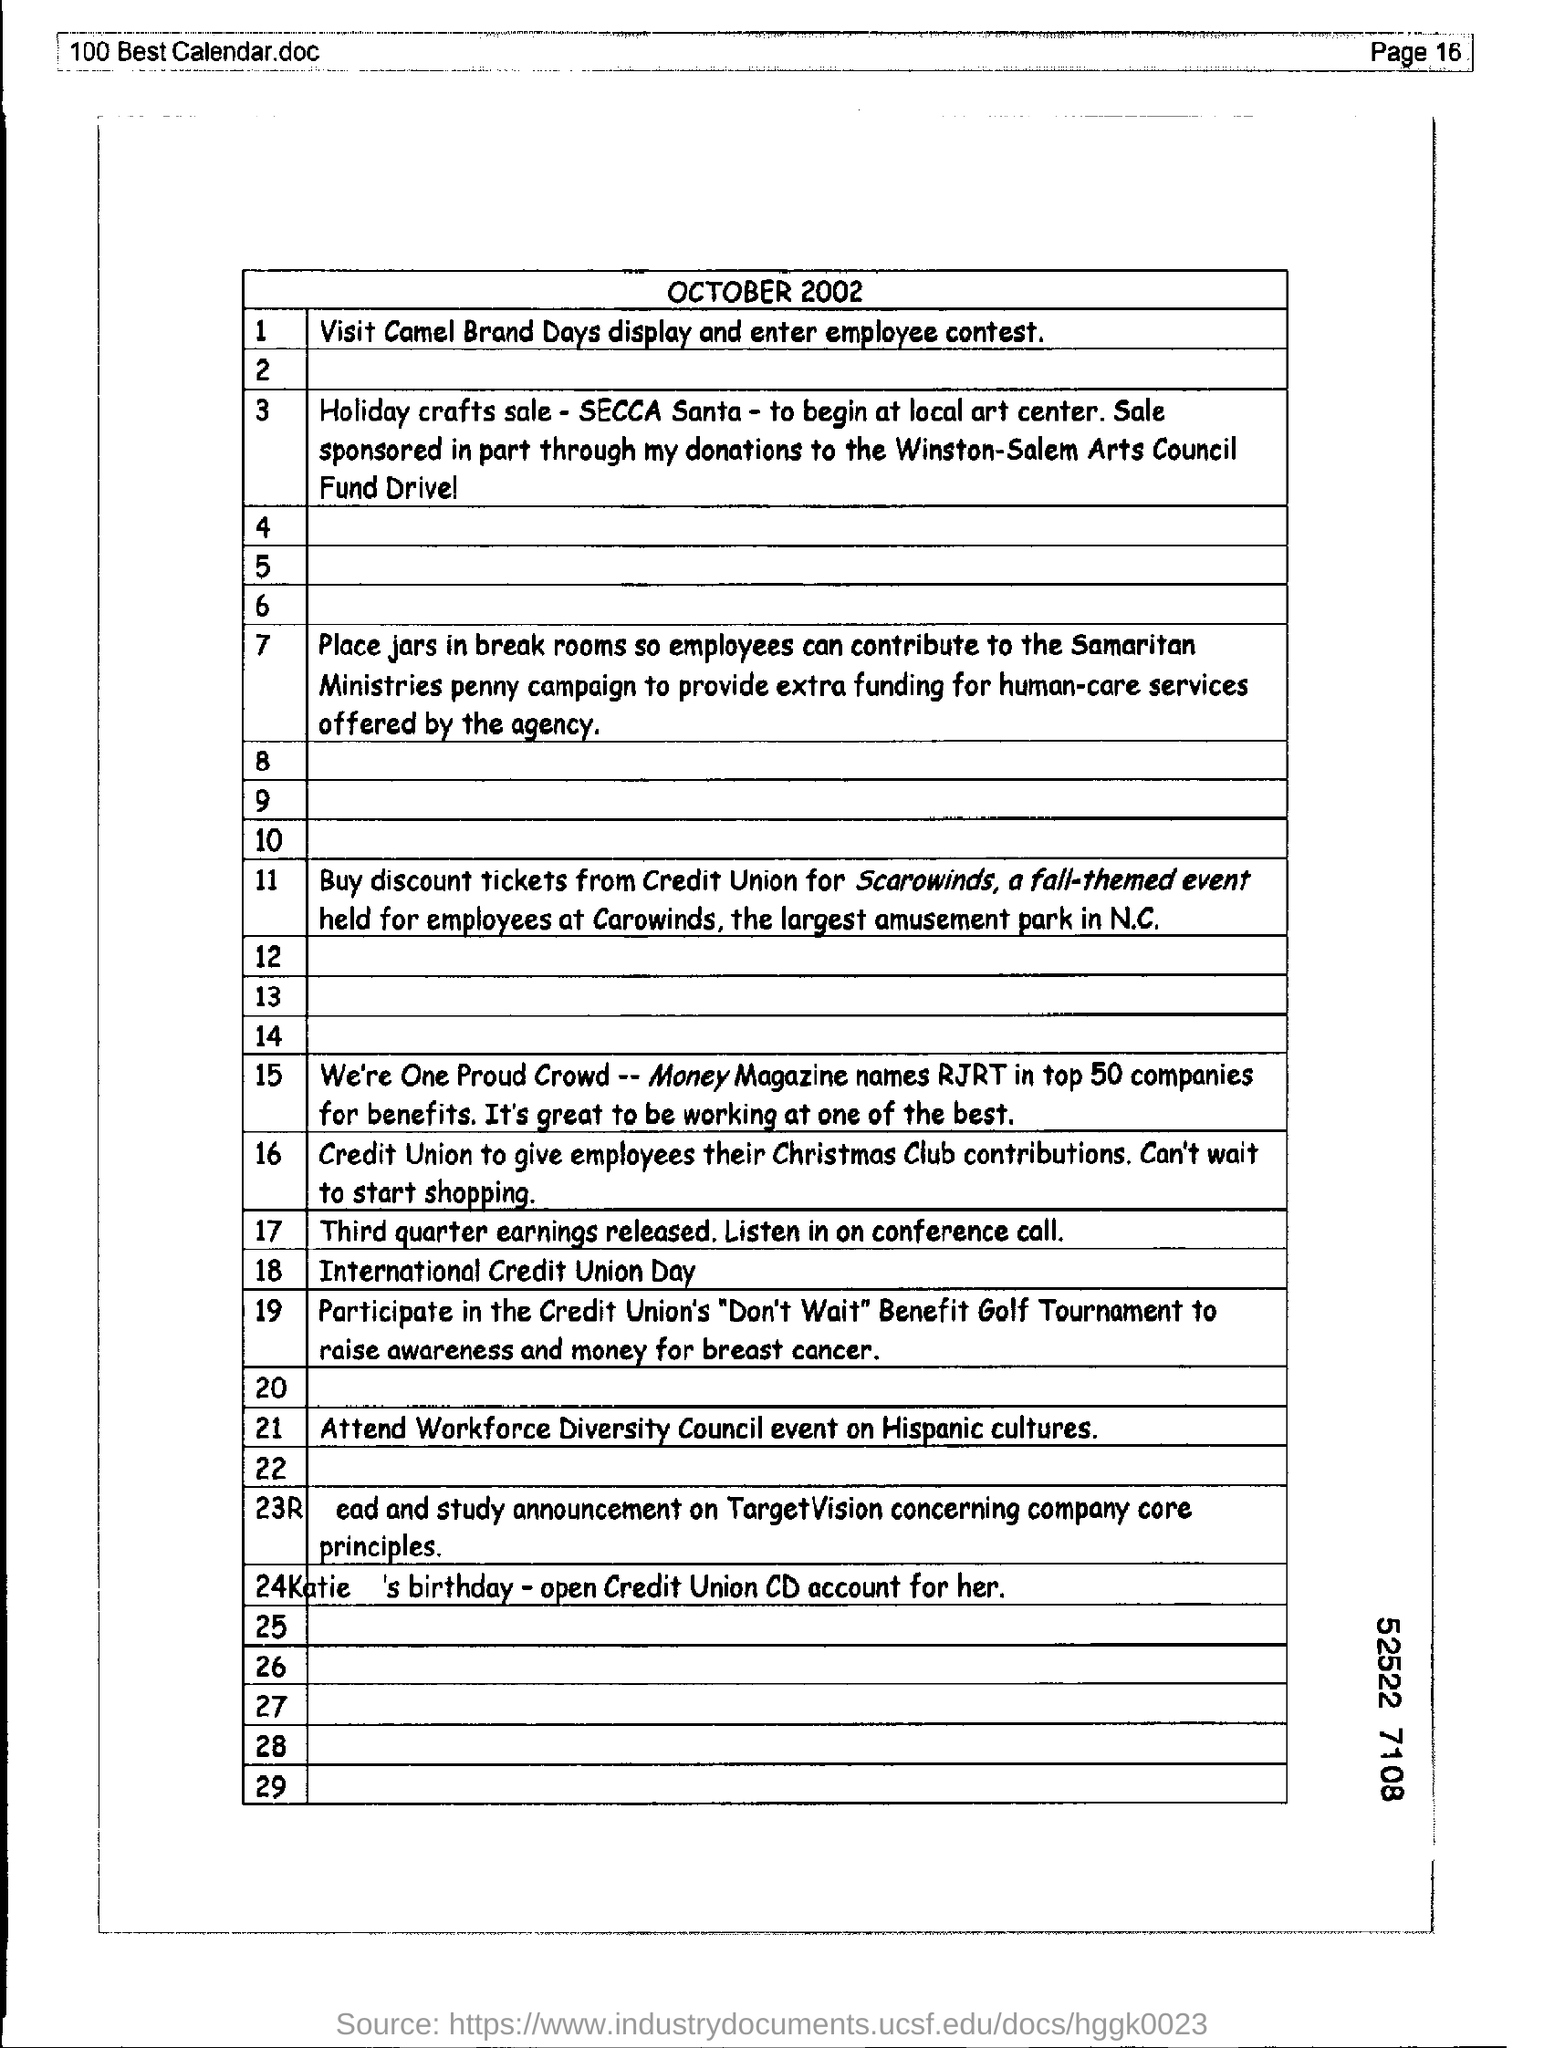What is the page number of the document?
Keep it short and to the point. 16. What is the month and year mentioned??
Provide a succinct answer. October 2002. 